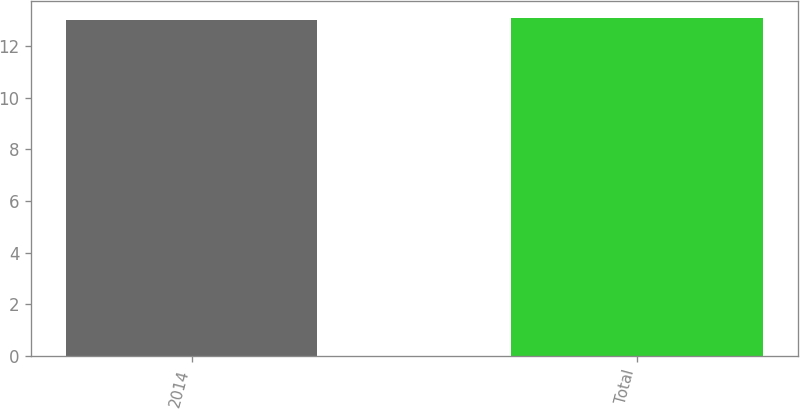<chart> <loc_0><loc_0><loc_500><loc_500><bar_chart><fcel>2014<fcel>Total<nl><fcel>13<fcel>13.1<nl></chart> 